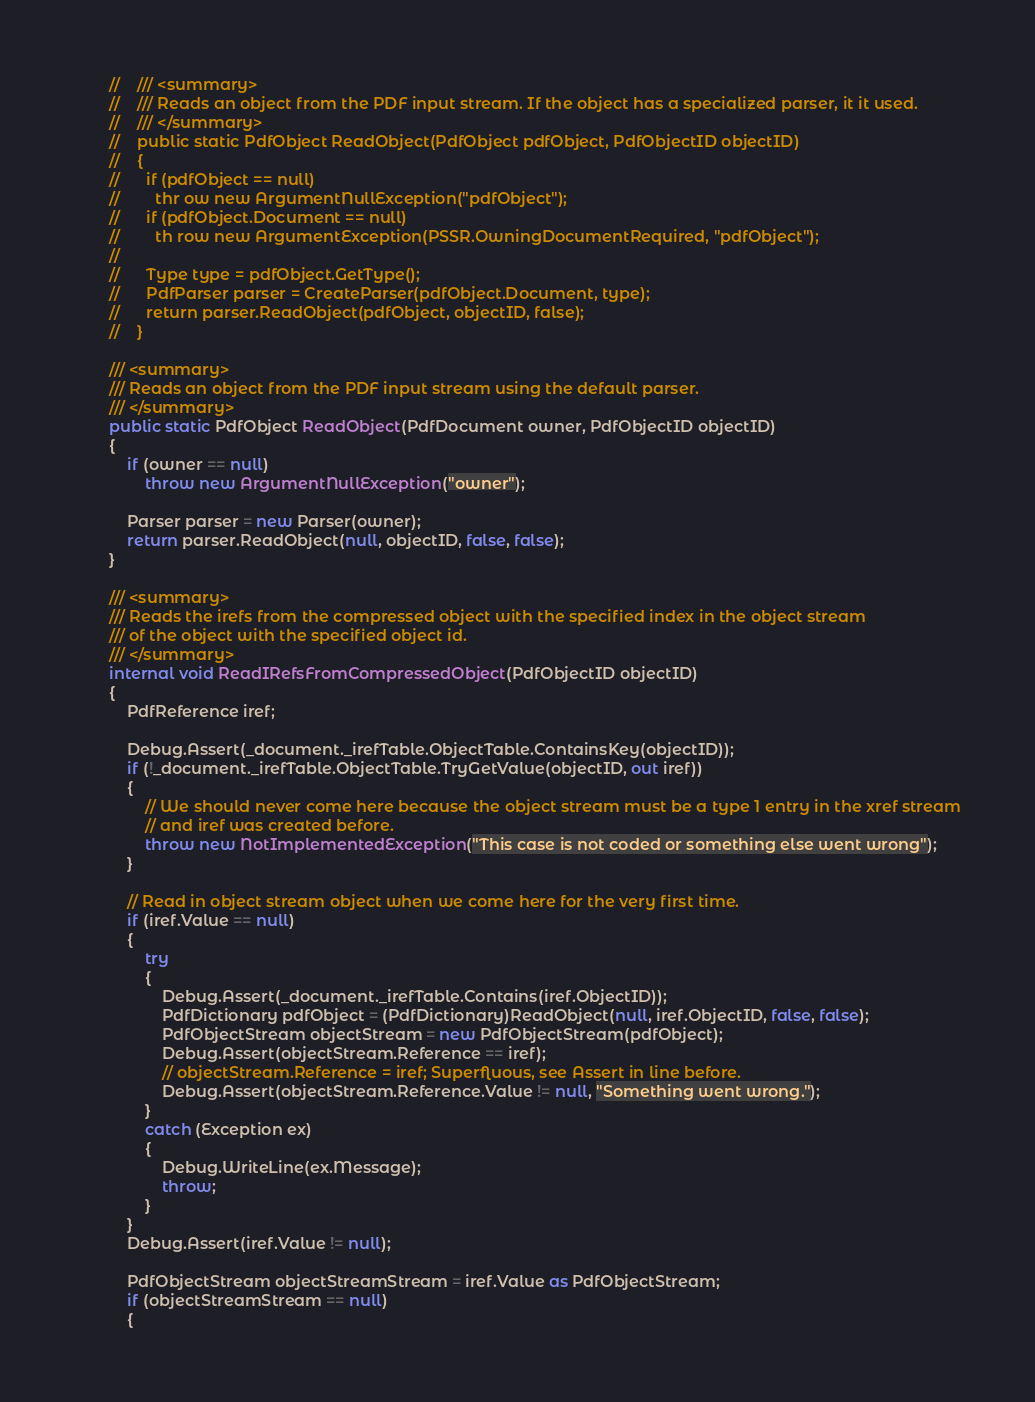<code> <loc_0><loc_0><loc_500><loc_500><_C#_>        //    /// <summary>
        //    /// Reads an object from the PDF input stream. If the object has a specialized parser, it it used.
        //    /// </summary>
        //    public static PdfObject ReadObject(PdfObject pdfObject, PdfObjectID objectID)
        //    {
        //      if (pdfObject == null)
        //        thr ow new ArgumentNullException("pdfObject");
        //      if (pdfObject.Document == null)
        //        th row new ArgumentException(PSSR.OwningDocumentRequired, "pdfObject");
        //
        //      Type type = pdfObject.GetType();
        //      PdfParser parser = CreateParser(pdfObject.Document, type);
        //      return parser.ReadObject(pdfObject, objectID, false);
        //    }

        /// <summary>
        /// Reads an object from the PDF input stream using the default parser.
        /// </summary>
        public static PdfObject ReadObject(PdfDocument owner, PdfObjectID objectID)
        {
            if (owner == null)
                throw new ArgumentNullException("owner");

            Parser parser = new Parser(owner);
            return parser.ReadObject(null, objectID, false, false);
        }

        /// <summary>
        /// Reads the irefs from the compressed object with the specified index in the object stream
        /// of the object with the specified object id.
        /// </summary>
        internal void ReadIRefsFromCompressedObject(PdfObjectID objectID)
        {
            PdfReference iref;

            Debug.Assert(_document._irefTable.ObjectTable.ContainsKey(objectID));
            if (!_document._irefTable.ObjectTable.TryGetValue(objectID, out iref))
            {
                // We should never come here because the object stream must be a type 1 entry in the xref stream
                // and iref was created before.
                throw new NotImplementedException("This case is not coded or something else went wrong");
            }

            // Read in object stream object when we come here for the very first time.
            if (iref.Value == null)
            {
                try
                {
                    Debug.Assert(_document._irefTable.Contains(iref.ObjectID));
                    PdfDictionary pdfObject = (PdfDictionary)ReadObject(null, iref.ObjectID, false, false);
                    PdfObjectStream objectStream = new PdfObjectStream(pdfObject);
                    Debug.Assert(objectStream.Reference == iref);
                    // objectStream.Reference = iref; Superfluous, see Assert in line before.
                    Debug.Assert(objectStream.Reference.Value != null, "Something went wrong.");
                }
                catch (Exception ex)
                {
                    Debug.WriteLine(ex.Message);
                    throw;
                }
            }
            Debug.Assert(iref.Value != null);

            PdfObjectStream objectStreamStream = iref.Value as PdfObjectStream;
            if (objectStreamStream == null)
            {</code> 